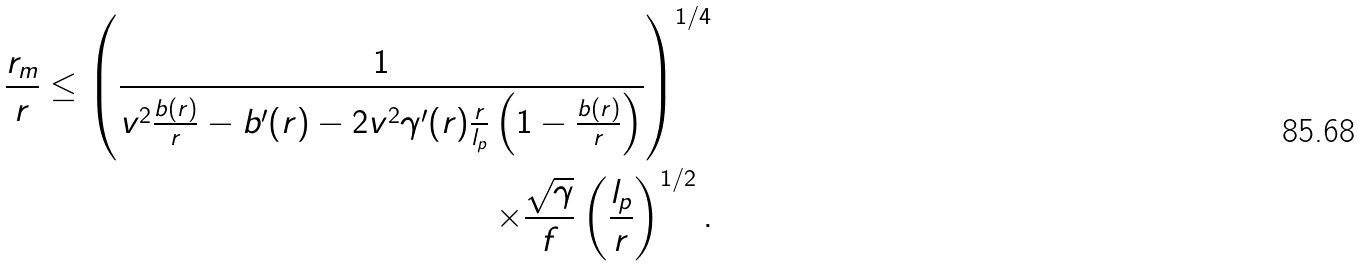Convert formula to latex. <formula><loc_0><loc_0><loc_500><loc_500>\frac { r _ { m } } { r } \leq \left ( \frac { 1 } { v ^ { 2 } \frac { b ( r ) } { r } - b ^ { \prime } ( r ) - 2 v ^ { 2 } \gamma ^ { \prime } ( r ) \frac { r } { l _ { p } } \left ( 1 - \frac { b ( r ) } { r } \right ) } \right ) ^ { 1 / 4 } \\ \times \frac { \sqrt { \gamma } } { f } \left ( \frac { l _ { p } } { r } \right ) ^ { 1 / 2 } .</formula> 